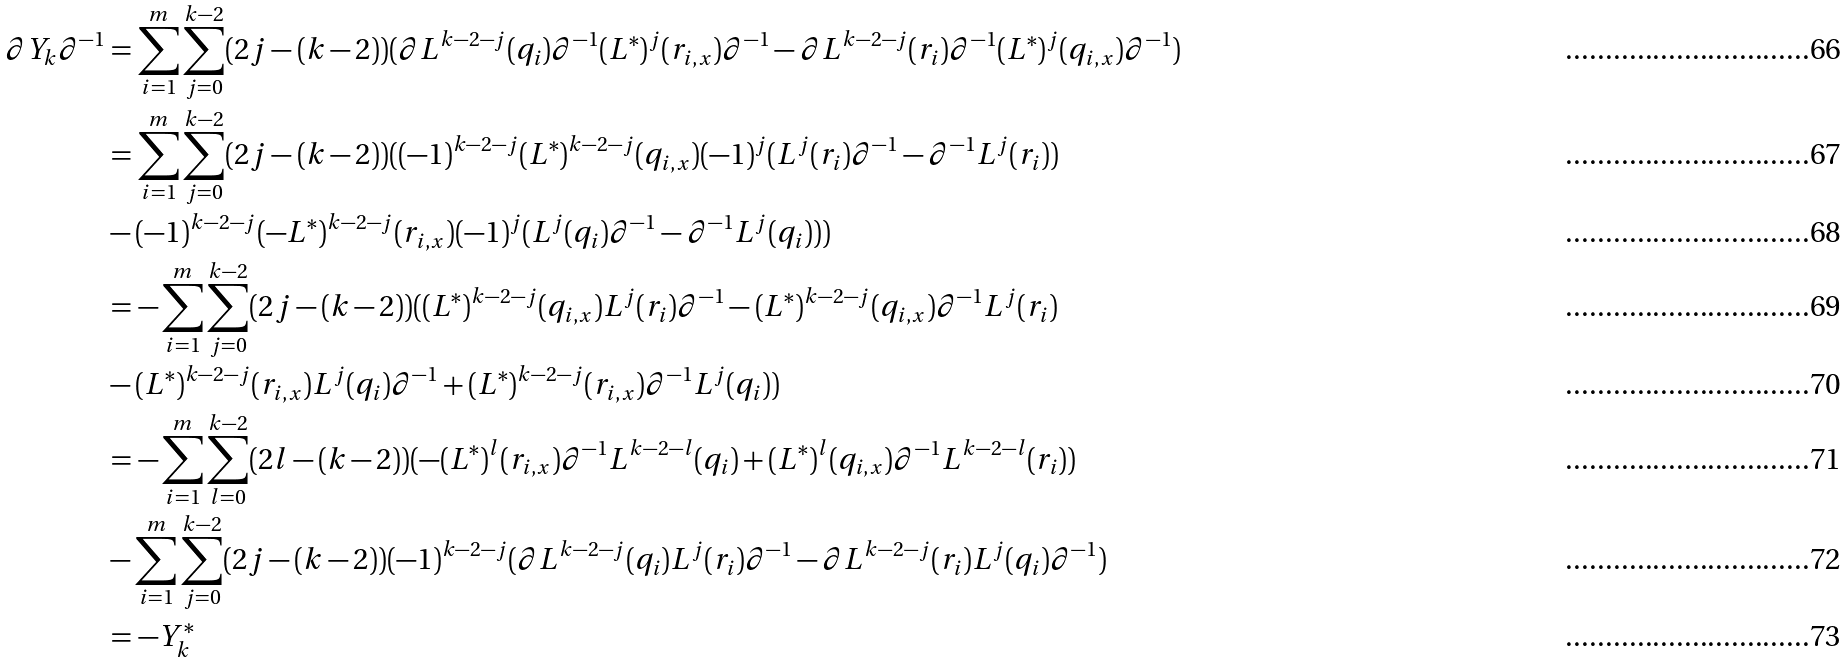<formula> <loc_0><loc_0><loc_500><loc_500>\partial Y _ { k } \partial ^ { - 1 } & = \sum _ { i = 1 } ^ { m } \sum _ { j = 0 } ^ { k - 2 } ( 2 j - ( k - 2 ) ) ( \partial L ^ { k - 2 - j } ( q _ { i } ) \partial ^ { - 1 } ( L ^ { * } ) ^ { j } ( r _ { i , x } ) \partial ^ { - 1 } - \partial L ^ { k - 2 - j } ( r _ { i } ) \partial ^ { - 1 } ( L ^ { * } ) ^ { j } ( q _ { i , x } ) \partial ^ { - 1 } ) \\ & = \sum _ { i = 1 } ^ { m } \sum _ { j = 0 } ^ { k - 2 } ( 2 j - ( k - 2 ) ) ( ( - 1 ) ^ { k - 2 - j } ( L ^ { * } ) ^ { k - 2 - j } ( q _ { i , x } ) ( - 1 ) ^ { j } ( L ^ { j } ( r _ { i } ) \partial ^ { - 1 } - \partial ^ { - 1 } L ^ { j } ( r _ { i } ) ) \\ & - ( - 1 ) ^ { k - 2 - j } ( - L ^ { * } ) ^ { k - 2 - j } ( r _ { i , x } ) ( - 1 ) ^ { j } ( L ^ { j } ( q _ { i } ) \partial ^ { - 1 } - \partial ^ { - 1 } L ^ { j } ( q _ { i } ) ) ) \\ & = - \sum _ { i = 1 } ^ { m } \sum _ { j = 0 } ^ { k - 2 } ( 2 j - ( k - 2 ) ) ( ( L ^ { * } ) ^ { k - 2 - j } ( q _ { i , x } ) L ^ { j } ( r _ { i } ) \partial ^ { - 1 } - ( L ^ { * } ) ^ { k - 2 - j } ( q _ { i , x } ) \partial ^ { - 1 } L ^ { j } ( r _ { i } ) \\ & - ( L ^ { * } ) ^ { k - 2 - j } ( r _ { i , x } ) L ^ { j } ( q _ { i } ) \partial ^ { - 1 } + ( L ^ { * } ) ^ { k - 2 - j } ( r _ { i , x } ) \partial ^ { - 1 } L ^ { j } ( q _ { i } ) ) \\ & = - \sum _ { i = 1 } ^ { m } \sum _ { l = 0 } ^ { k - 2 } ( 2 l - ( k - 2 ) ) ( - ( L ^ { * } ) ^ { l } ( r _ { i , x } ) \partial ^ { - 1 } L ^ { k - 2 - l } ( q _ { i } ) + ( L ^ { * } ) ^ { l } ( q _ { i , x } ) \partial ^ { - 1 } L ^ { k - 2 - l } ( r _ { i } ) ) \\ & - \sum _ { i = 1 } ^ { m } \sum _ { j = 0 } ^ { k - 2 } ( 2 j - ( k - 2 ) ) ( - 1 ) ^ { k - 2 - j } ( \partial L ^ { k - 2 - j } ( q _ { i } ) L ^ { j } ( r _ { i } ) \partial ^ { - 1 } - \partial L ^ { k - 2 - j } ( r _ { i } ) L ^ { j } ( q _ { i } ) \partial ^ { - 1 } ) \\ & = - Y _ { k } ^ { * }</formula> 